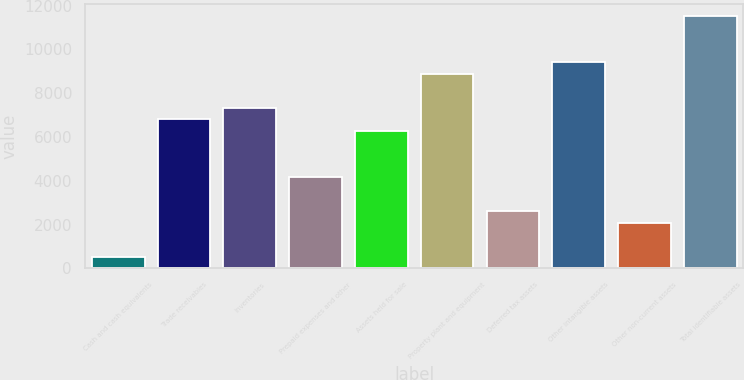<chart> <loc_0><loc_0><loc_500><loc_500><bar_chart><fcel>Cash and cash equivalents<fcel>Trade receivables<fcel>Inventories<fcel>Prepaid expenses and other<fcel>Assets held for sale<fcel>Property plant and equipment<fcel>Deferred tax assets<fcel>Other intangible assets<fcel>Other non-current assets<fcel>Total identifiable assets<nl><fcel>524.49<fcel>6797.97<fcel>7320.76<fcel>4184.02<fcel>6275.18<fcel>8889.13<fcel>2615.65<fcel>9411.92<fcel>2092.86<fcel>11503.1<nl></chart> 